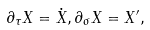Convert formula to latex. <formula><loc_0><loc_0><loc_500><loc_500>\partial _ { \tau } X = \dot { X } , \partial _ { \sigma } X = X ^ { \prime } ,</formula> 